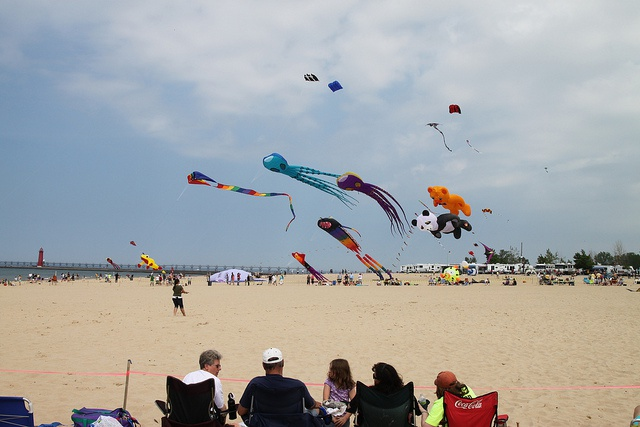Describe the objects in this image and their specific colors. I can see people in darkgray, gray, tan, and black tones, people in darkgray, black, lightgray, maroon, and gray tones, kite in darkgray, black, and navy tones, chair in darkgray, black, and gray tones, and chair in darkgray, black, and gray tones in this image. 